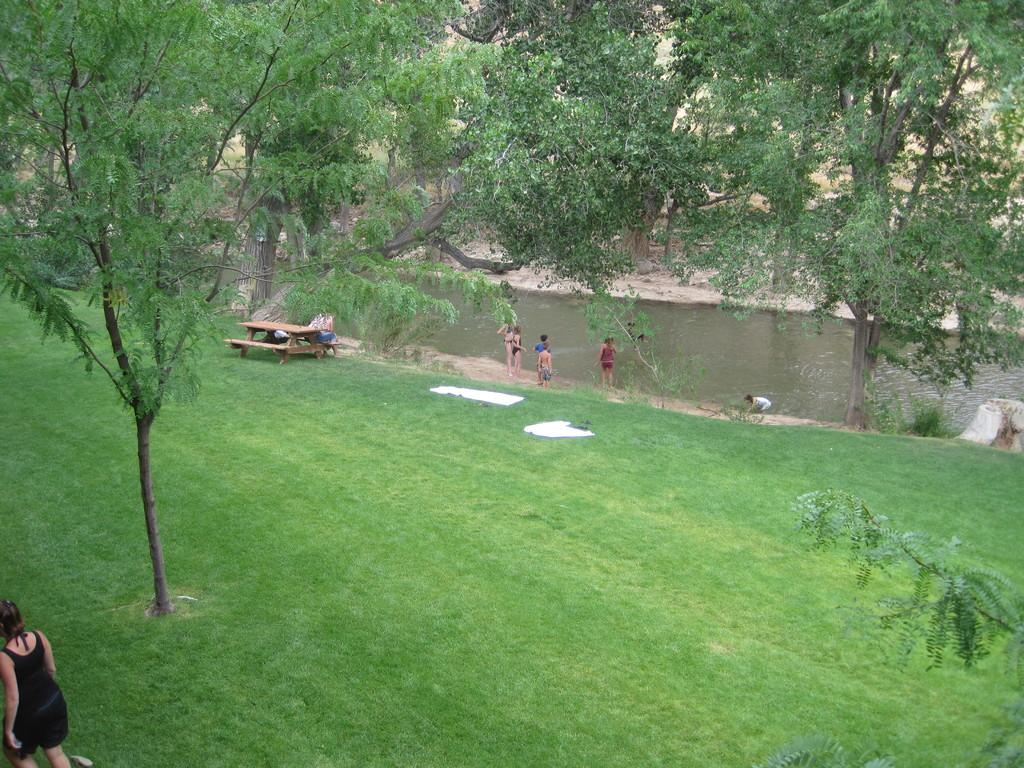What type of vegetation is present in the image? There is grass in the image. What items are related to seating in the image? There are benches in the image. What object is used for placing items on in the image? There is a table in the image. What can be seen in the background of the image? There are trees in the background of the image. What is the natural element visible in the image? There is water visible in the image. Are there any people present in the image? Yes, there are people in the image. What type of pollution can be seen in the image? There is no pollution visible in the image. What type of material is the table made of in the image? The provided facts do not mention the material of the table, so it cannot be determined from the image. 